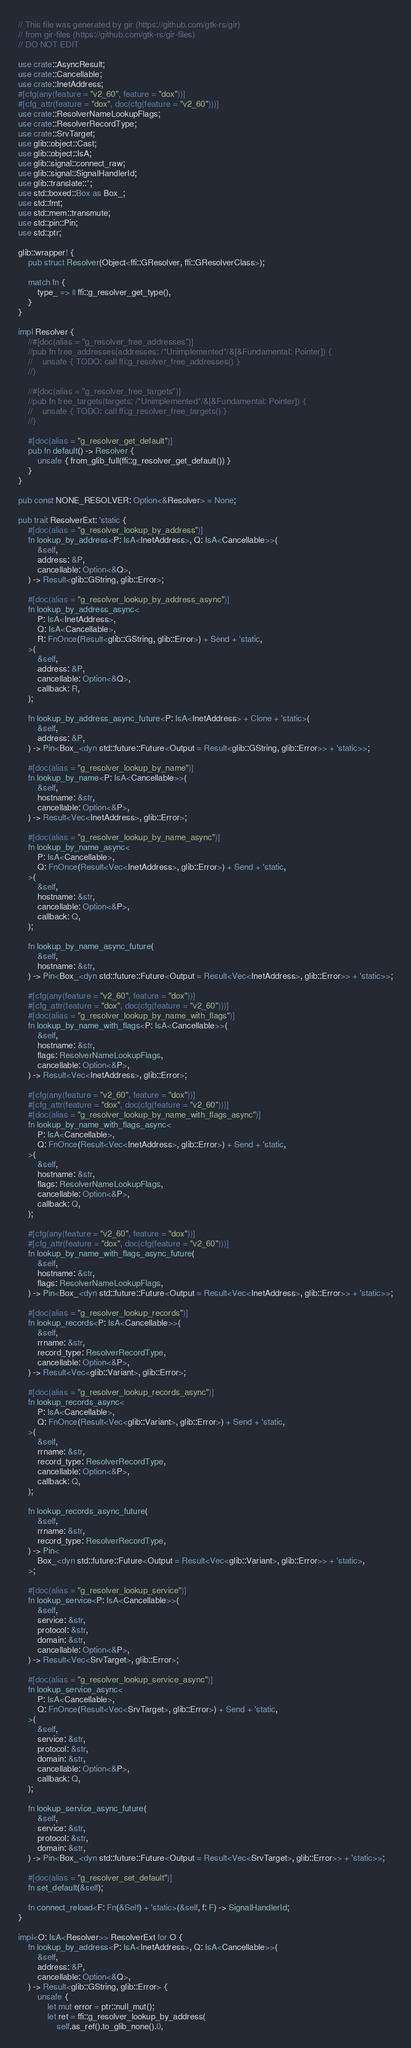<code> <loc_0><loc_0><loc_500><loc_500><_Rust_>// This file was generated by gir (https://github.com/gtk-rs/gir)
// from gir-files (https://github.com/gtk-rs/gir-files)
// DO NOT EDIT

use crate::AsyncResult;
use crate::Cancellable;
use crate::InetAddress;
#[cfg(any(feature = "v2_60", feature = "dox"))]
#[cfg_attr(feature = "dox", doc(cfg(feature = "v2_60")))]
use crate::ResolverNameLookupFlags;
use crate::ResolverRecordType;
use crate::SrvTarget;
use glib::object::Cast;
use glib::object::IsA;
use glib::signal::connect_raw;
use glib::signal::SignalHandlerId;
use glib::translate::*;
use std::boxed::Box as Box_;
use std::fmt;
use std::mem::transmute;
use std::pin::Pin;
use std::ptr;

glib::wrapper! {
    pub struct Resolver(Object<ffi::GResolver, ffi::GResolverClass>);

    match fn {
        type_ => || ffi::g_resolver_get_type(),
    }
}

impl Resolver {
    //#[doc(alias = "g_resolver_free_addresses")]
    //pub fn free_addresses(addresses: /*Unimplemented*/&[&Fundamental: Pointer]) {
    //    unsafe { TODO: call ffi:g_resolver_free_addresses() }
    //}

    //#[doc(alias = "g_resolver_free_targets")]
    //pub fn free_targets(targets: /*Unimplemented*/&[&Fundamental: Pointer]) {
    //    unsafe { TODO: call ffi:g_resolver_free_targets() }
    //}

    #[doc(alias = "g_resolver_get_default")]
    pub fn default() -> Resolver {
        unsafe { from_glib_full(ffi::g_resolver_get_default()) }
    }
}

pub const NONE_RESOLVER: Option<&Resolver> = None;

pub trait ResolverExt: 'static {
    #[doc(alias = "g_resolver_lookup_by_address")]
    fn lookup_by_address<P: IsA<InetAddress>, Q: IsA<Cancellable>>(
        &self,
        address: &P,
        cancellable: Option<&Q>,
    ) -> Result<glib::GString, glib::Error>;

    #[doc(alias = "g_resolver_lookup_by_address_async")]
    fn lookup_by_address_async<
        P: IsA<InetAddress>,
        Q: IsA<Cancellable>,
        R: FnOnce(Result<glib::GString, glib::Error>) + Send + 'static,
    >(
        &self,
        address: &P,
        cancellable: Option<&Q>,
        callback: R,
    );

    fn lookup_by_address_async_future<P: IsA<InetAddress> + Clone + 'static>(
        &self,
        address: &P,
    ) -> Pin<Box_<dyn std::future::Future<Output = Result<glib::GString, glib::Error>> + 'static>>;

    #[doc(alias = "g_resolver_lookup_by_name")]
    fn lookup_by_name<P: IsA<Cancellable>>(
        &self,
        hostname: &str,
        cancellable: Option<&P>,
    ) -> Result<Vec<InetAddress>, glib::Error>;

    #[doc(alias = "g_resolver_lookup_by_name_async")]
    fn lookup_by_name_async<
        P: IsA<Cancellable>,
        Q: FnOnce(Result<Vec<InetAddress>, glib::Error>) + Send + 'static,
    >(
        &self,
        hostname: &str,
        cancellable: Option<&P>,
        callback: Q,
    );

    fn lookup_by_name_async_future(
        &self,
        hostname: &str,
    ) -> Pin<Box_<dyn std::future::Future<Output = Result<Vec<InetAddress>, glib::Error>> + 'static>>;

    #[cfg(any(feature = "v2_60", feature = "dox"))]
    #[cfg_attr(feature = "dox", doc(cfg(feature = "v2_60")))]
    #[doc(alias = "g_resolver_lookup_by_name_with_flags")]
    fn lookup_by_name_with_flags<P: IsA<Cancellable>>(
        &self,
        hostname: &str,
        flags: ResolverNameLookupFlags,
        cancellable: Option<&P>,
    ) -> Result<Vec<InetAddress>, glib::Error>;

    #[cfg(any(feature = "v2_60", feature = "dox"))]
    #[cfg_attr(feature = "dox", doc(cfg(feature = "v2_60")))]
    #[doc(alias = "g_resolver_lookup_by_name_with_flags_async")]
    fn lookup_by_name_with_flags_async<
        P: IsA<Cancellable>,
        Q: FnOnce(Result<Vec<InetAddress>, glib::Error>) + Send + 'static,
    >(
        &self,
        hostname: &str,
        flags: ResolverNameLookupFlags,
        cancellable: Option<&P>,
        callback: Q,
    );

    #[cfg(any(feature = "v2_60", feature = "dox"))]
    #[cfg_attr(feature = "dox", doc(cfg(feature = "v2_60")))]
    fn lookup_by_name_with_flags_async_future(
        &self,
        hostname: &str,
        flags: ResolverNameLookupFlags,
    ) -> Pin<Box_<dyn std::future::Future<Output = Result<Vec<InetAddress>, glib::Error>> + 'static>>;

    #[doc(alias = "g_resolver_lookup_records")]
    fn lookup_records<P: IsA<Cancellable>>(
        &self,
        rrname: &str,
        record_type: ResolverRecordType,
        cancellable: Option<&P>,
    ) -> Result<Vec<glib::Variant>, glib::Error>;

    #[doc(alias = "g_resolver_lookup_records_async")]
    fn lookup_records_async<
        P: IsA<Cancellable>,
        Q: FnOnce(Result<Vec<glib::Variant>, glib::Error>) + Send + 'static,
    >(
        &self,
        rrname: &str,
        record_type: ResolverRecordType,
        cancellable: Option<&P>,
        callback: Q,
    );

    fn lookup_records_async_future(
        &self,
        rrname: &str,
        record_type: ResolverRecordType,
    ) -> Pin<
        Box_<dyn std::future::Future<Output = Result<Vec<glib::Variant>, glib::Error>> + 'static>,
    >;

    #[doc(alias = "g_resolver_lookup_service")]
    fn lookup_service<P: IsA<Cancellable>>(
        &self,
        service: &str,
        protocol: &str,
        domain: &str,
        cancellable: Option<&P>,
    ) -> Result<Vec<SrvTarget>, glib::Error>;

    #[doc(alias = "g_resolver_lookup_service_async")]
    fn lookup_service_async<
        P: IsA<Cancellable>,
        Q: FnOnce(Result<Vec<SrvTarget>, glib::Error>) + Send + 'static,
    >(
        &self,
        service: &str,
        protocol: &str,
        domain: &str,
        cancellable: Option<&P>,
        callback: Q,
    );

    fn lookup_service_async_future(
        &self,
        service: &str,
        protocol: &str,
        domain: &str,
    ) -> Pin<Box_<dyn std::future::Future<Output = Result<Vec<SrvTarget>, glib::Error>> + 'static>>;

    #[doc(alias = "g_resolver_set_default")]
    fn set_default(&self);

    fn connect_reload<F: Fn(&Self) + 'static>(&self, f: F) -> SignalHandlerId;
}

impl<O: IsA<Resolver>> ResolverExt for O {
    fn lookup_by_address<P: IsA<InetAddress>, Q: IsA<Cancellable>>(
        &self,
        address: &P,
        cancellable: Option<&Q>,
    ) -> Result<glib::GString, glib::Error> {
        unsafe {
            let mut error = ptr::null_mut();
            let ret = ffi::g_resolver_lookup_by_address(
                self.as_ref().to_glib_none().0,</code> 